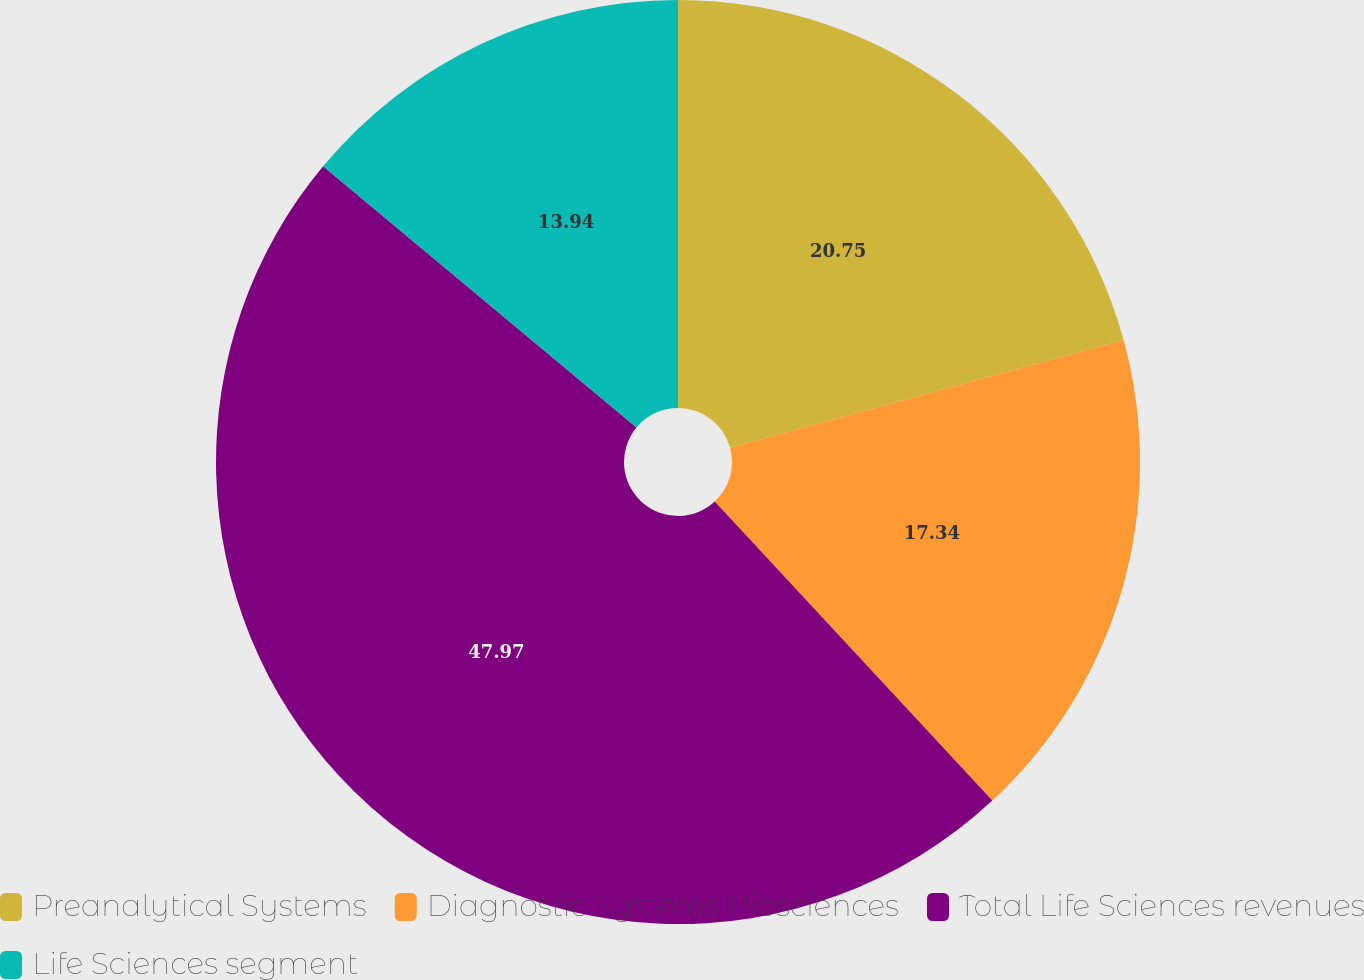Convert chart. <chart><loc_0><loc_0><loc_500><loc_500><pie_chart><fcel>Preanalytical Systems<fcel>Diagnostic Systems Biosciences<fcel>Total Life Sciences revenues<fcel>Life Sciences segment<nl><fcel>20.75%<fcel>17.34%<fcel>47.97%<fcel>13.94%<nl></chart> 